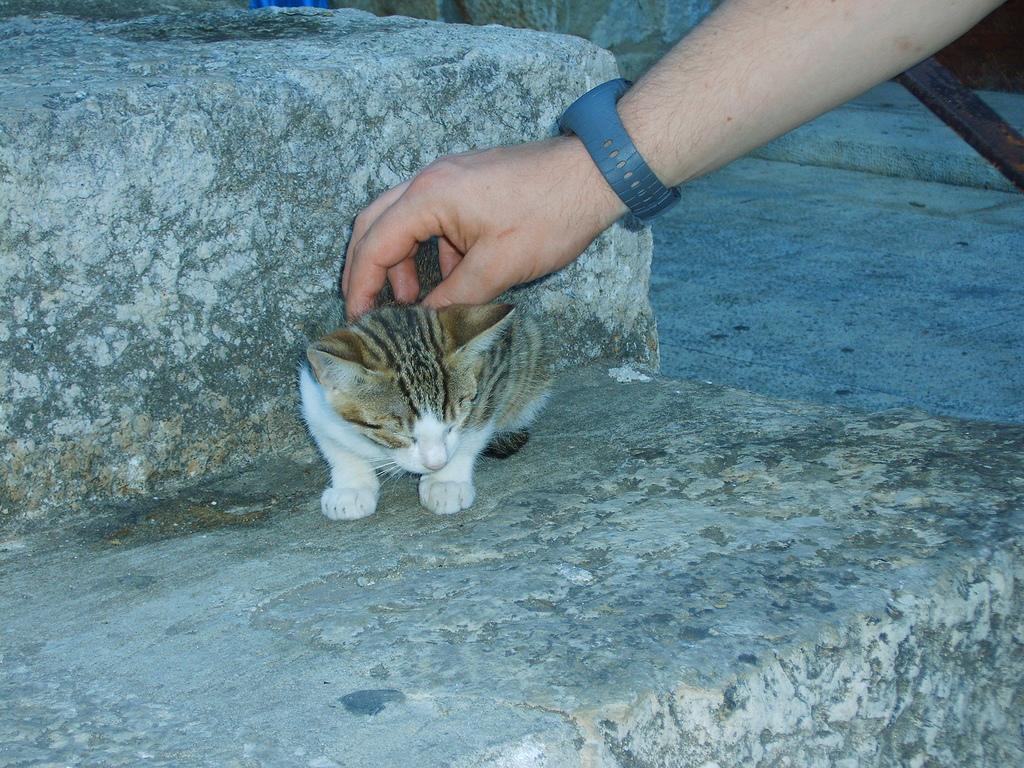In one or two sentences, can you explain what this image depicts? In this image there is a cat sitting on a rock. A person is keeping his hand on the cat. He is wearing a watch. Right side there is a floor. 